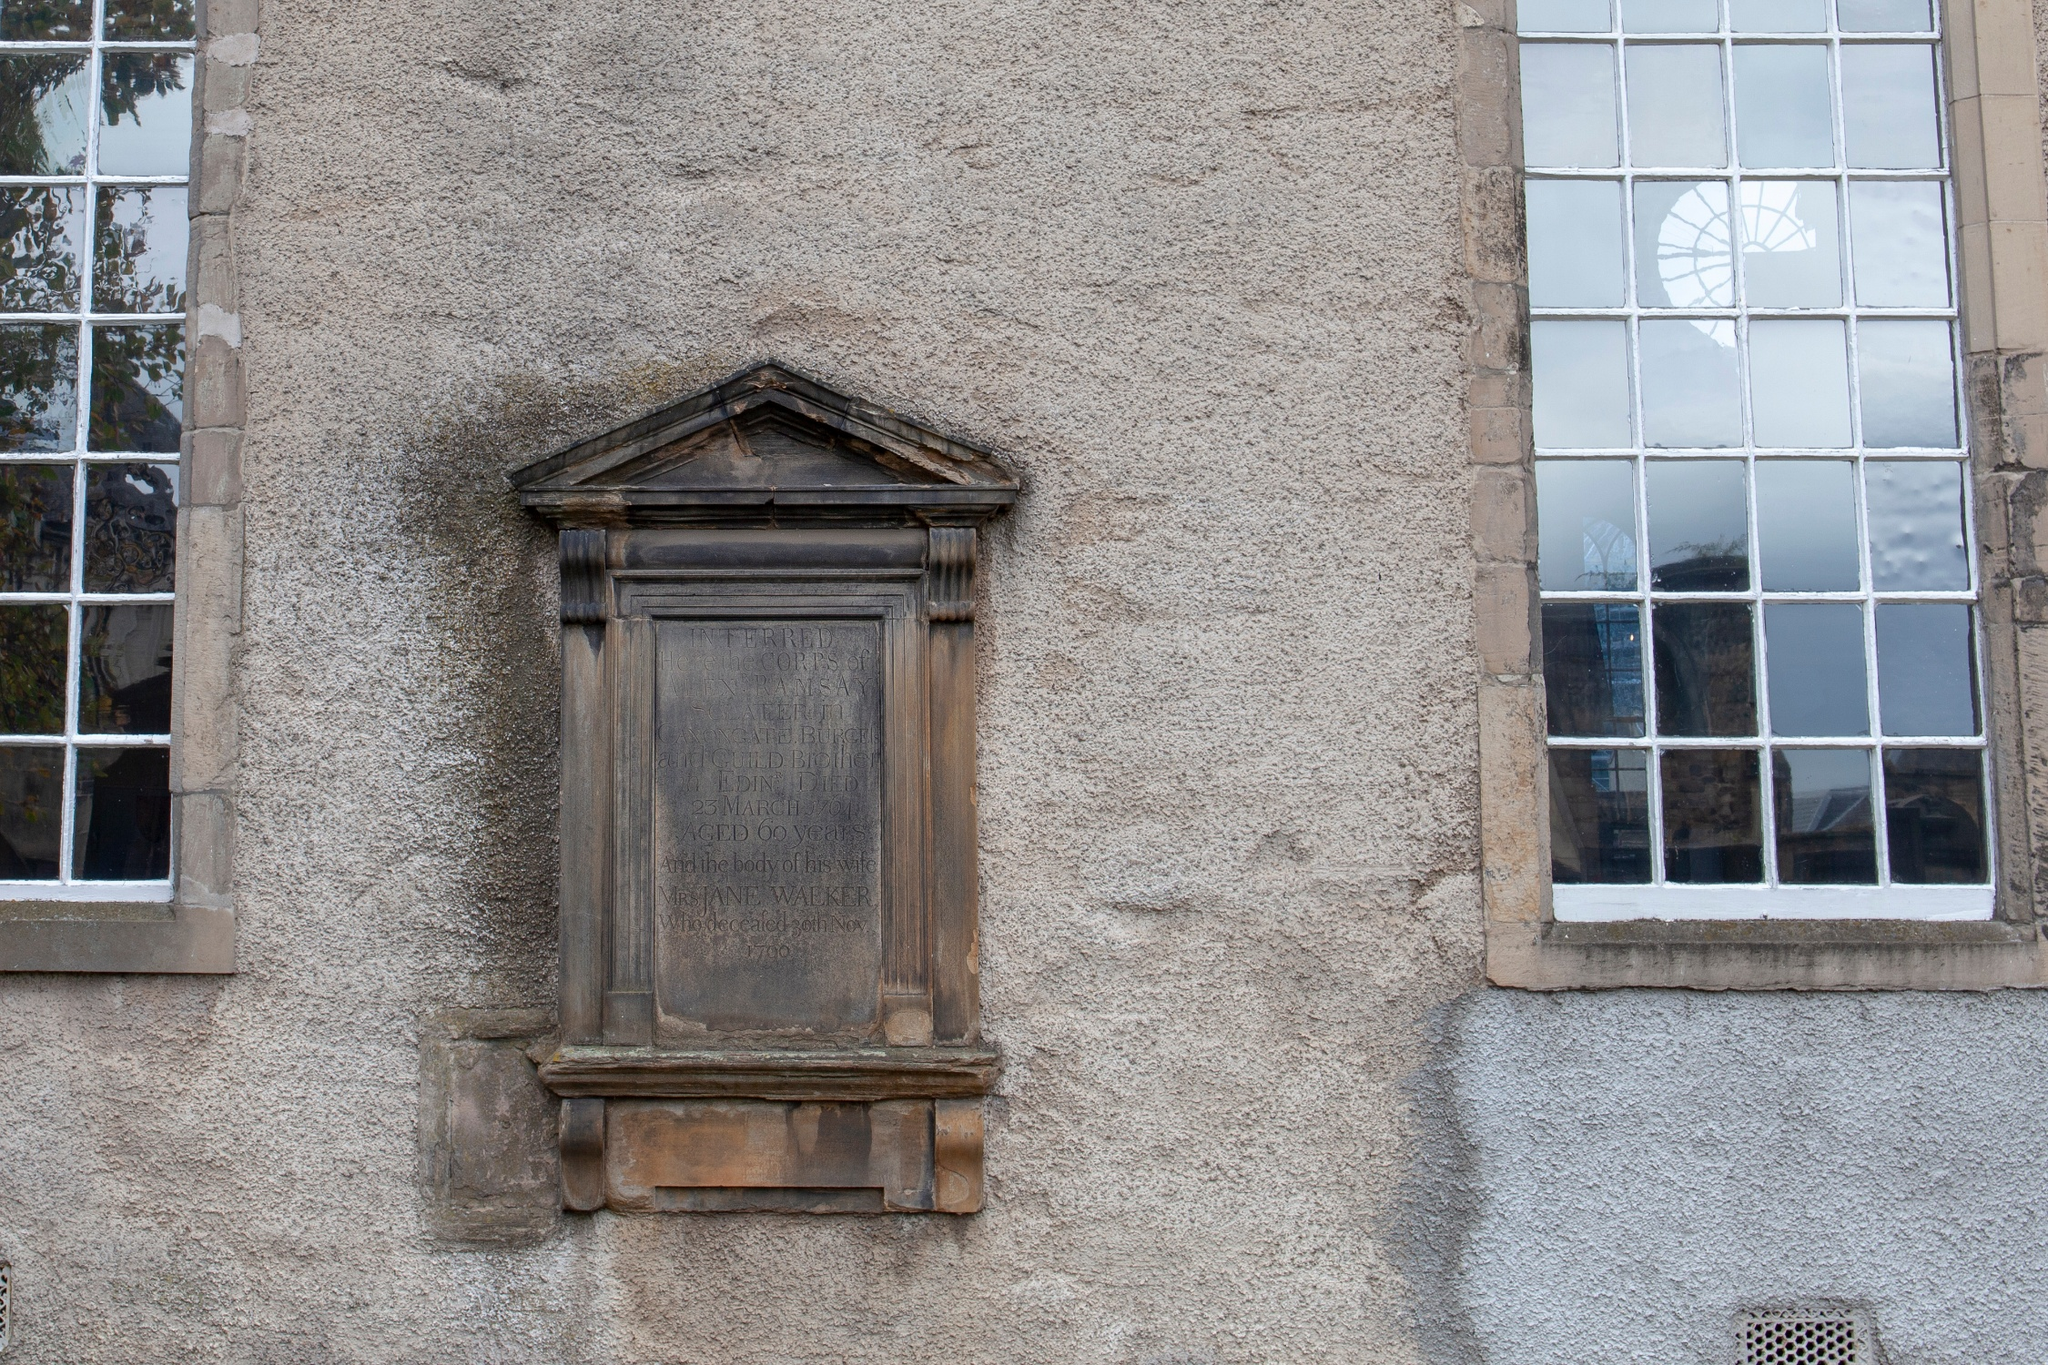Could there be any specific events associated with this location? While specific events cannot be determined without further historical context, the building’s style and the presence of the commemorative plaque suggest it could have been a significant site in the community. It may have hosted important gatherings or been involved in notable historical events. The architectural significance and positioning of elements like the plaque typically denote a place of importance, whether cultural, political, or social. Research into local historical records or an expert consultation could potentially reveal more about any events tied to this location. 